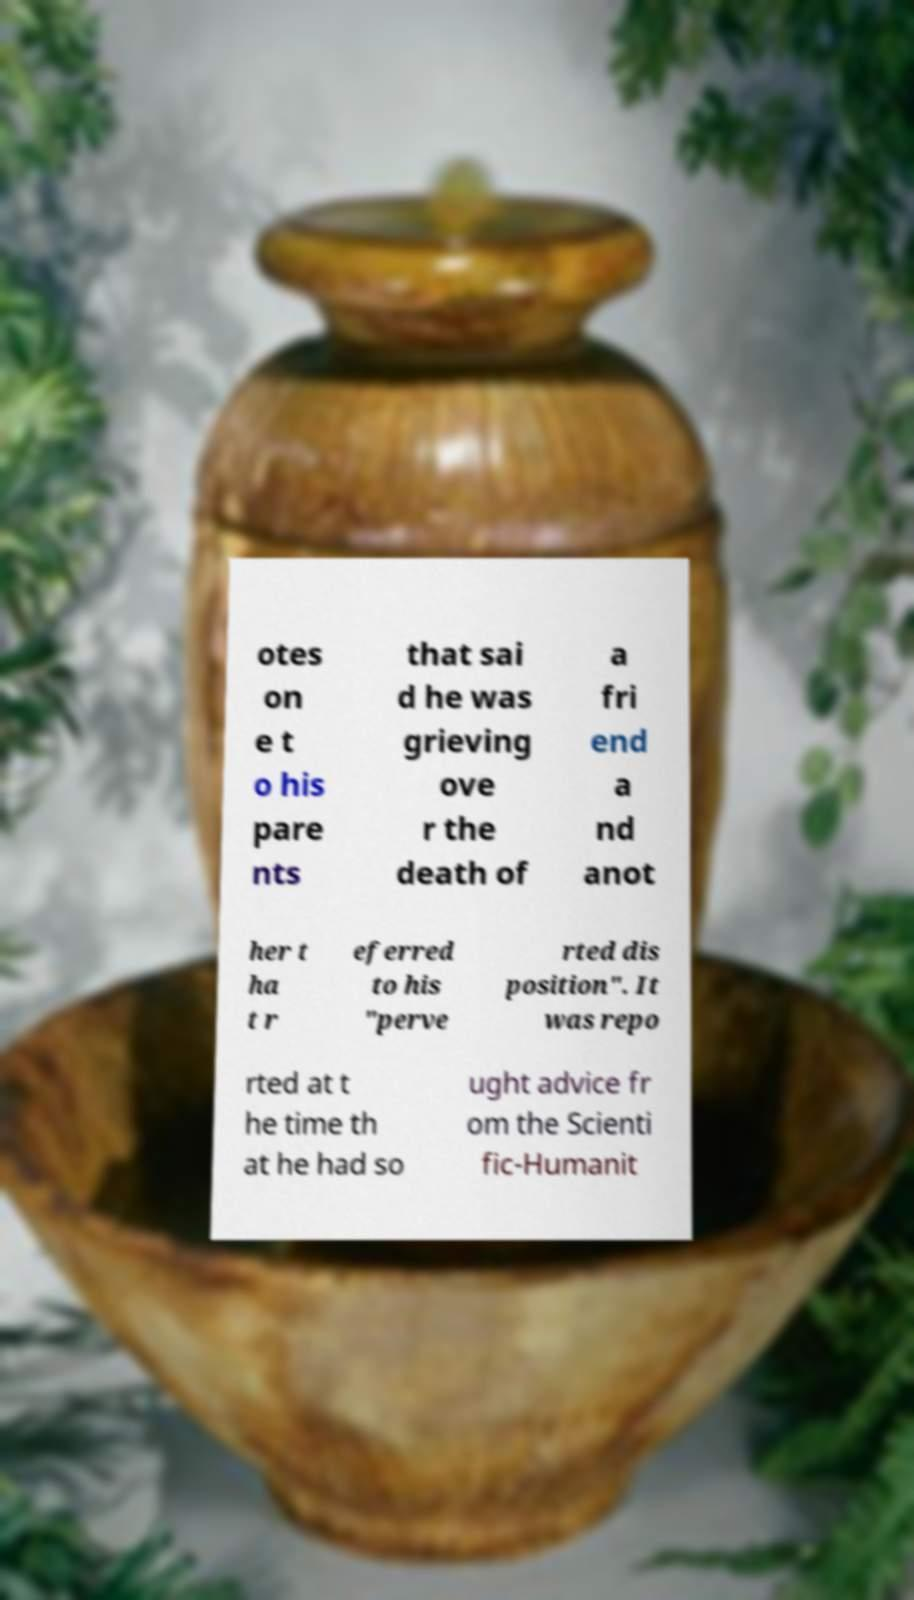I need the written content from this picture converted into text. Can you do that? otes on e t o his pare nts that sai d he was grieving ove r the death of a fri end a nd anot her t ha t r eferred to his "perve rted dis position". It was repo rted at t he time th at he had so ught advice fr om the Scienti fic-Humanit 